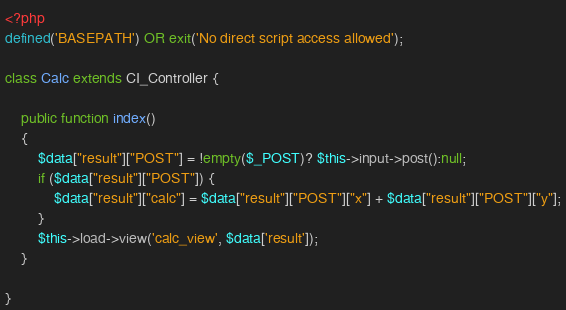Convert code to text. <code><loc_0><loc_0><loc_500><loc_500><_PHP_><?php
defined('BASEPATH') OR exit('No direct script access allowed');

class Calc extends CI_Controller {

	public function index()
	{
		$data["result"]["POST"] = !empty($_POST)? $this->input->post():null;
		if ($data["result"]["POST"]) {
			$data["result"]["calc"] = $data["result"]["POST"]["x"] + $data["result"]["POST"]["y"];
		}
		$this->load->view('calc_view', $data['result']);		
	}

}
</code> 